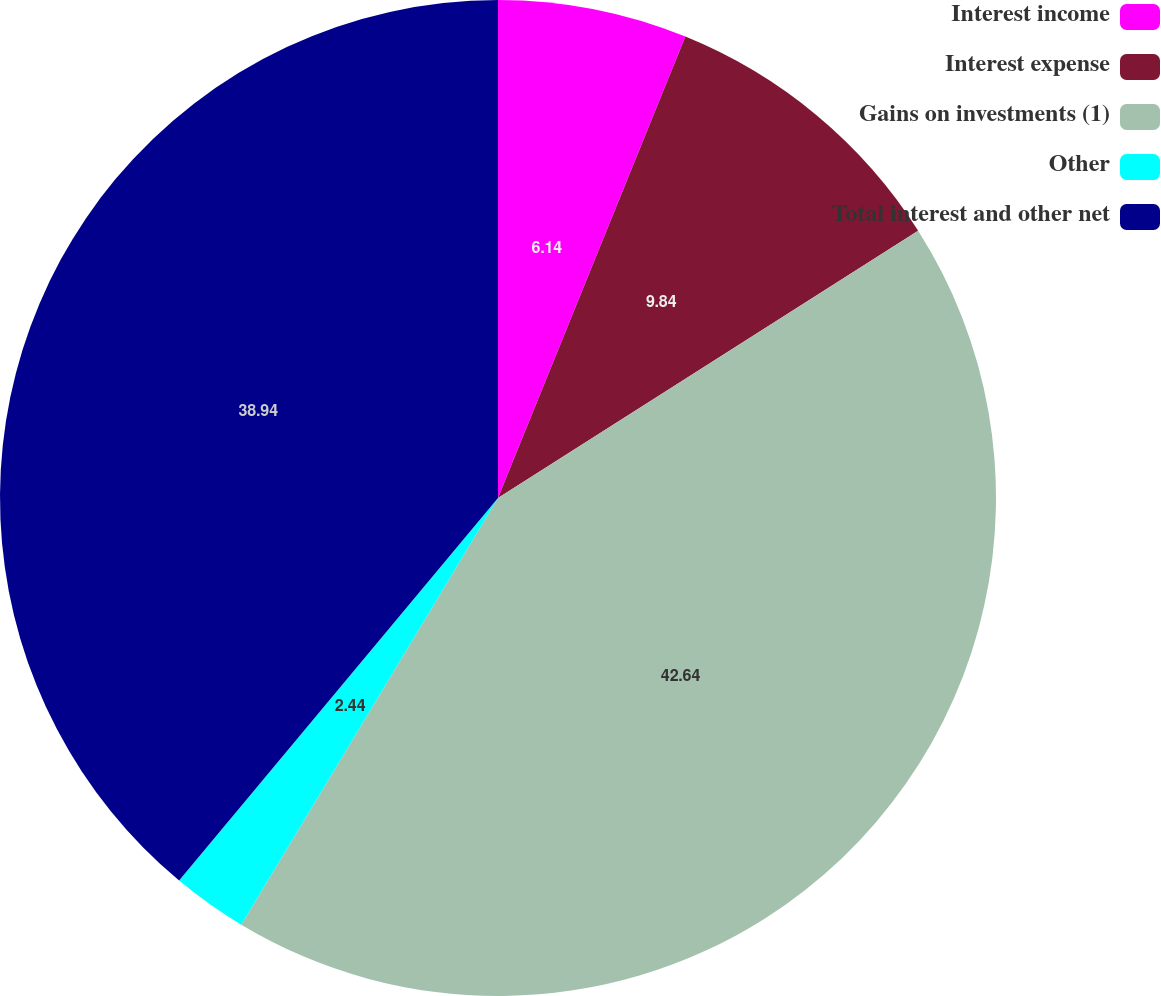Convert chart to OTSL. <chart><loc_0><loc_0><loc_500><loc_500><pie_chart><fcel>Interest income<fcel>Interest expense<fcel>Gains on investments (1)<fcel>Other<fcel>Total interest and other net<nl><fcel>6.14%<fcel>9.84%<fcel>42.64%<fcel>2.44%<fcel>38.94%<nl></chart> 